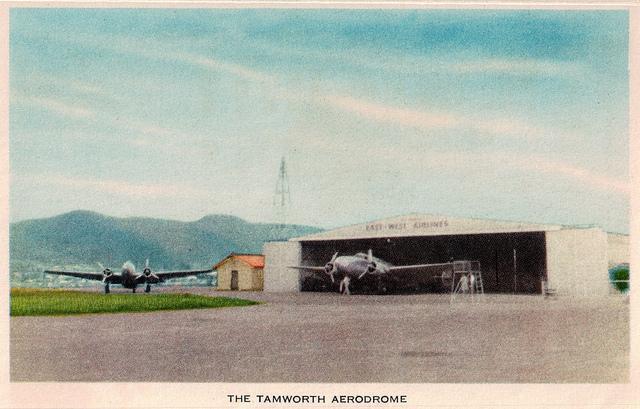How many planes are shown?
Give a very brief answer. 2. How many planes?
Give a very brief answer. 2. How many birds are there?
Give a very brief answer. 0. 